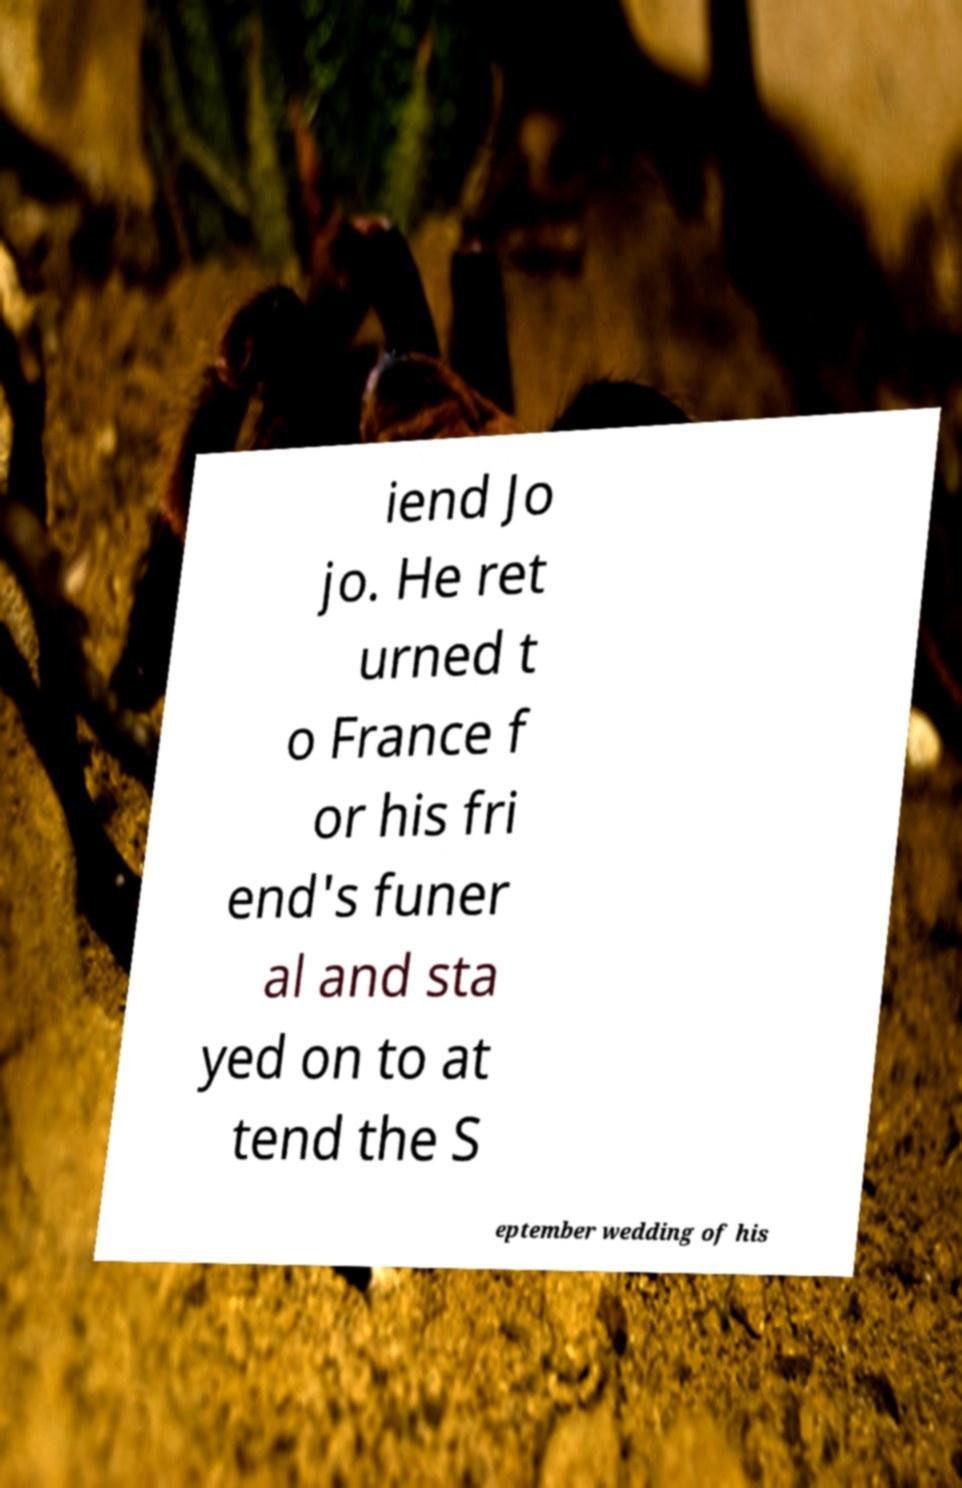What messages or text are displayed in this image? I need them in a readable, typed format. iend Jo jo. He ret urned t o France f or his fri end's funer al and sta yed on to at tend the S eptember wedding of his 